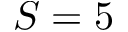Convert formula to latex. <formula><loc_0><loc_0><loc_500><loc_500>S = 5</formula> 